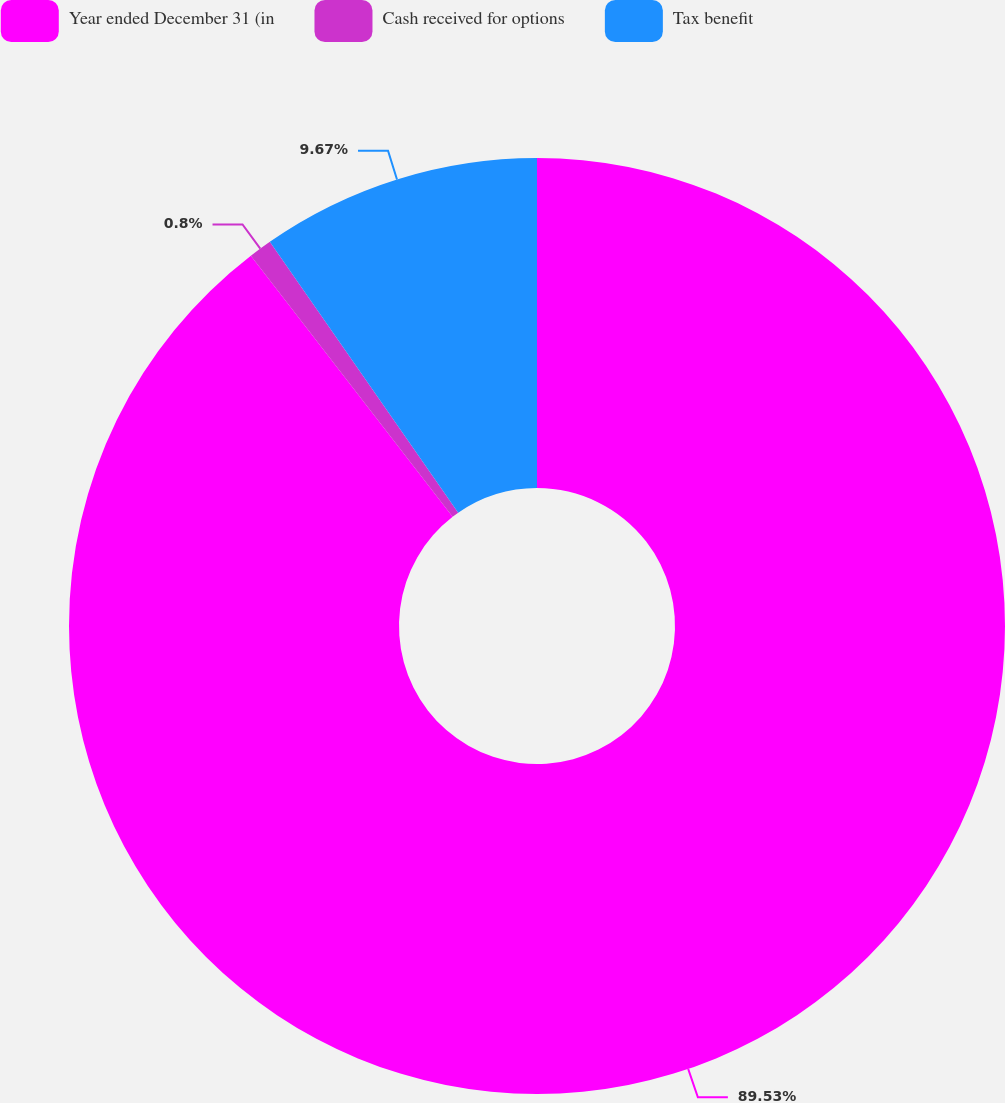<chart> <loc_0><loc_0><loc_500><loc_500><pie_chart><fcel>Year ended December 31 (in<fcel>Cash received for options<fcel>Tax benefit<nl><fcel>89.53%<fcel>0.8%<fcel>9.67%<nl></chart> 